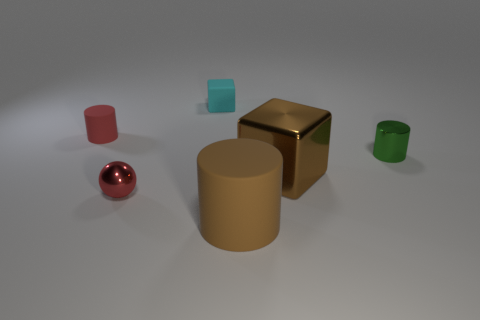There is a matte cylinder that is the same size as the metallic ball; what color is it?
Ensure brevity in your answer.  Red. Is the cyan thing the same size as the green metal object?
Provide a succinct answer. Yes. There is a green cylinder; how many small shiny things are on the left side of it?
Provide a succinct answer. 1. How many things are either matte cubes that are behind the brown metal thing or large yellow blocks?
Offer a very short reply. 1. Is the number of tiny rubber blocks that are right of the metallic cylinder greater than the number of tiny red balls that are behind the cyan thing?
Offer a terse response. No. The object that is the same color as the big cube is what size?
Provide a succinct answer. Large. There is a brown rubber cylinder; is its size the same as the matte cylinder that is behind the green cylinder?
Provide a succinct answer. No. How many cylinders are cyan rubber things or red shiny objects?
Offer a terse response. 0. There is a brown thing that is the same material as the red cylinder; what is its size?
Ensure brevity in your answer.  Large. There is a red object behind the tiny red metallic sphere; is it the same size as the red object that is in front of the metal cylinder?
Keep it short and to the point. Yes. 